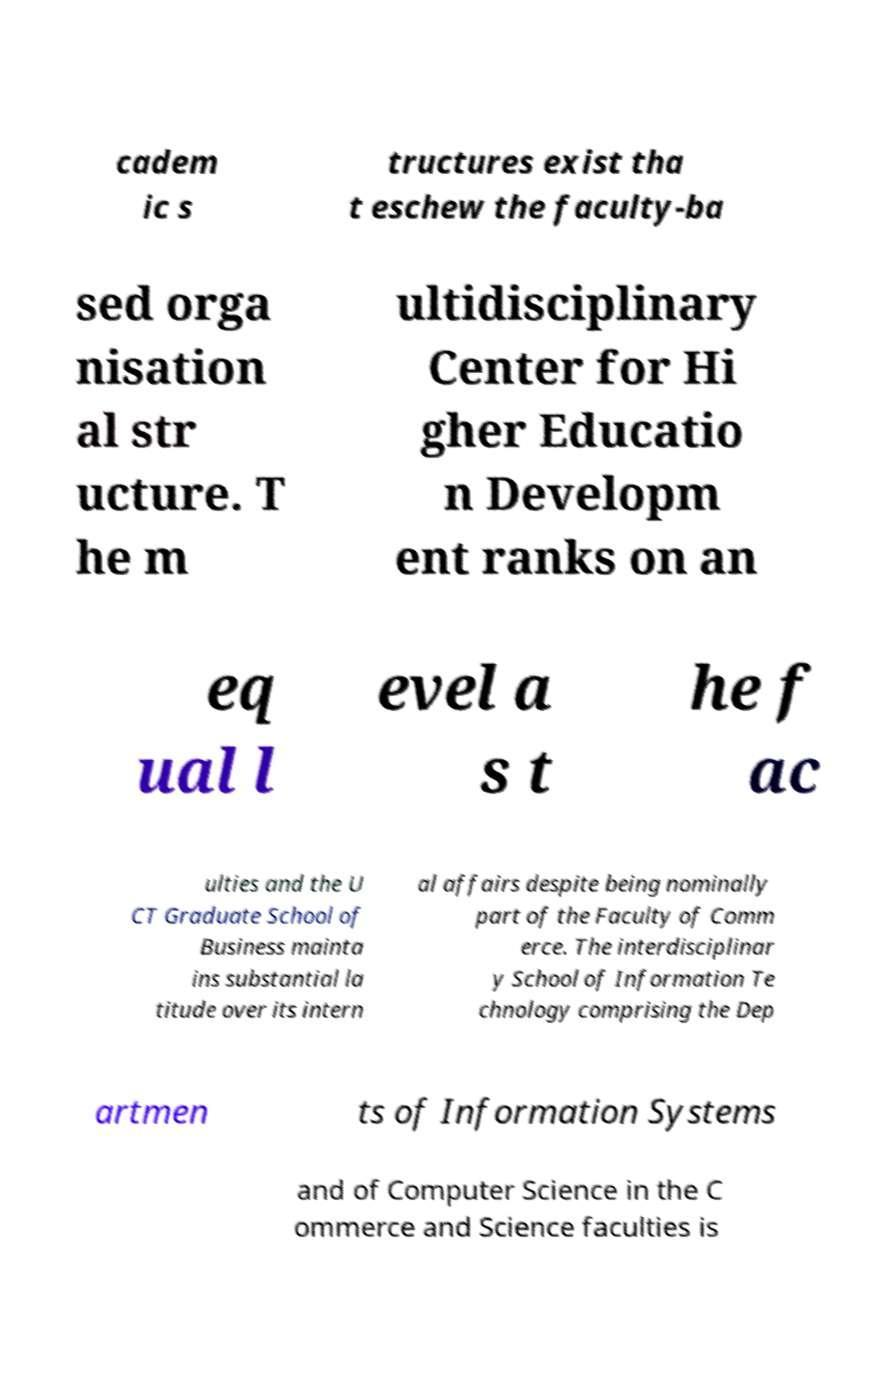Please read and relay the text visible in this image. What does it say? cadem ic s tructures exist tha t eschew the faculty-ba sed orga nisation al str ucture. T he m ultidisciplinary Center for Hi gher Educatio n Developm ent ranks on an eq ual l evel a s t he f ac ulties and the U CT Graduate School of Business mainta ins substantial la titude over its intern al affairs despite being nominally part of the Faculty of Comm erce. The interdisciplinar y School of Information Te chnology comprising the Dep artmen ts of Information Systems and of Computer Science in the C ommerce and Science faculties is 